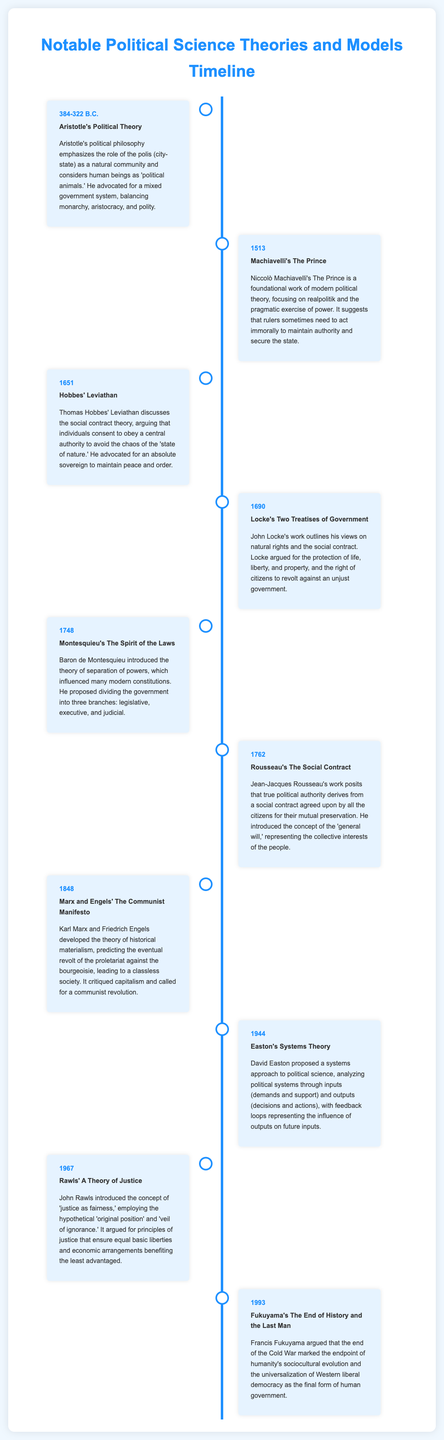what year was Aristotle's Political Theory published? Aristotle's Political Theory was developed between 384-322 B.C.
Answer: 384-322 B.C who authored The Prince? The work The Prince was authored by Niccolò Machiavelli.
Answer: Niccolò Machiavelli what theory does Hobbes' Leviathan discuss? Hobbes' Leviathan discusses the social contract theory.
Answer: social contract theory what concept did Montesquieu introduce? Montesquieu introduced the theory of separation of powers.
Answer: separation of powers when was The Communist Manifesto published? The Communist Manifesto was published in 1848.
Answer: 1848 what does Rawls' A Theory of Justice argue for? Rawls' A Theory of Justice argues for principles of justice that ensure equal basic liberties.
Answer: principles of justice what book did Fukuyama write in 1993? Fukuyama wrote The End of History and the Last Man in 1993.
Answer: The End of History and the Last Man what is the main focus of Easton's Systems Theory? Easton's Systems Theory focuses on analyzing political systems through inputs and outputs.
Answer: inputs and outputs which philosopher introduced the concept of the 'general will'? The concept of the 'general will' was introduced by Jean-Jacques Rousseau.
Answer: Jean-Jacques Rousseau 